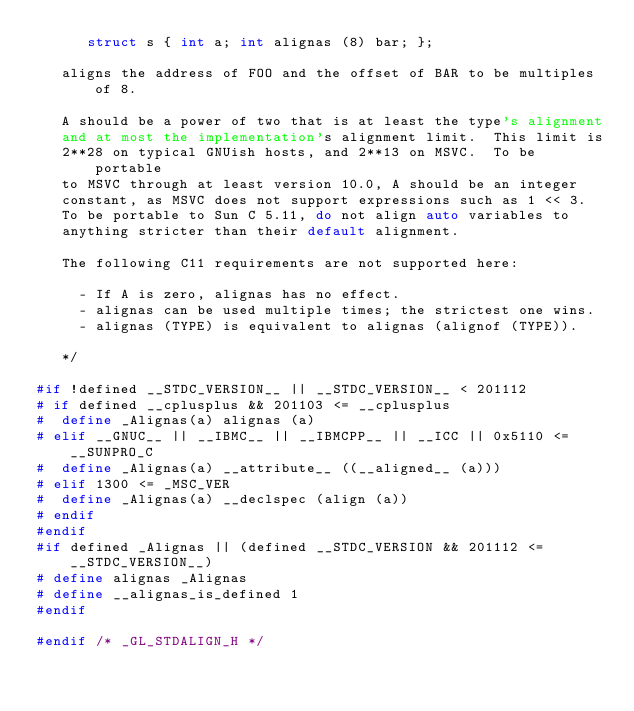<code> <loc_0><loc_0><loc_500><loc_500><_C_>      struct s { int a; int alignas (8) bar; };

   aligns the address of FOO and the offset of BAR to be multiples of 8.

   A should be a power of two that is at least the type's alignment
   and at most the implementation's alignment limit.  This limit is
   2**28 on typical GNUish hosts, and 2**13 on MSVC.  To be portable
   to MSVC through at least version 10.0, A should be an integer
   constant, as MSVC does not support expressions such as 1 << 3.
   To be portable to Sun C 5.11, do not align auto variables to
   anything stricter than their default alignment.

   The following C11 requirements are not supported here:

     - If A is zero, alignas has no effect.
     - alignas can be used multiple times; the strictest one wins.
     - alignas (TYPE) is equivalent to alignas (alignof (TYPE)).

   */

#if !defined __STDC_VERSION__ || __STDC_VERSION__ < 201112
# if defined __cplusplus && 201103 <= __cplusplus
#  define _Alignas(a) alignas (a)
# elif __GNUC__ || __IBMC__ || __IBMCPP__ || __ICC || 0x5110 <= __SUNPRO_C
#  define _Alignas(a) __attribute__ ((__aligned__ (a)))
# elif 1300 <= _MSC_VER
#  define _Alignas(a) __declspec (align (a))
# endif
#endif
#if defined _Alignas || (defined __STDC_VERSION && 201112 <= __STDC_VERSION__)
# define alignas _Alignas
# define __alignas_is_defined 1
#endif

#endif /* _GL_STDALIGN_H */
</code> 